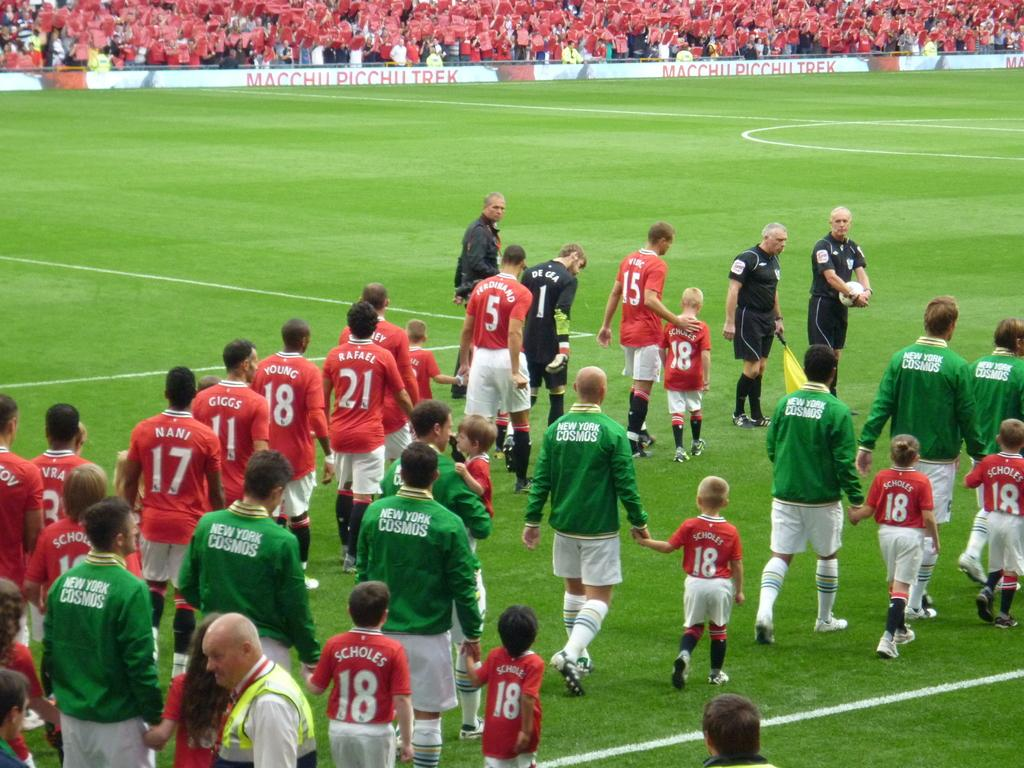What is happening in the foreground of the image? There are people on the ground in the image. What can be seen in the background of the image? There is an advertisement board and a group of people in the background of the image. What type of news is being reported on the umbrella in the image? There is no umbrella present in the image, and therefore no news can be reported on it. How many waves can be seen crashing on the shore in the image? There is no shore or waves present in the image; it features people on the ground and an advertisement board in the background. 